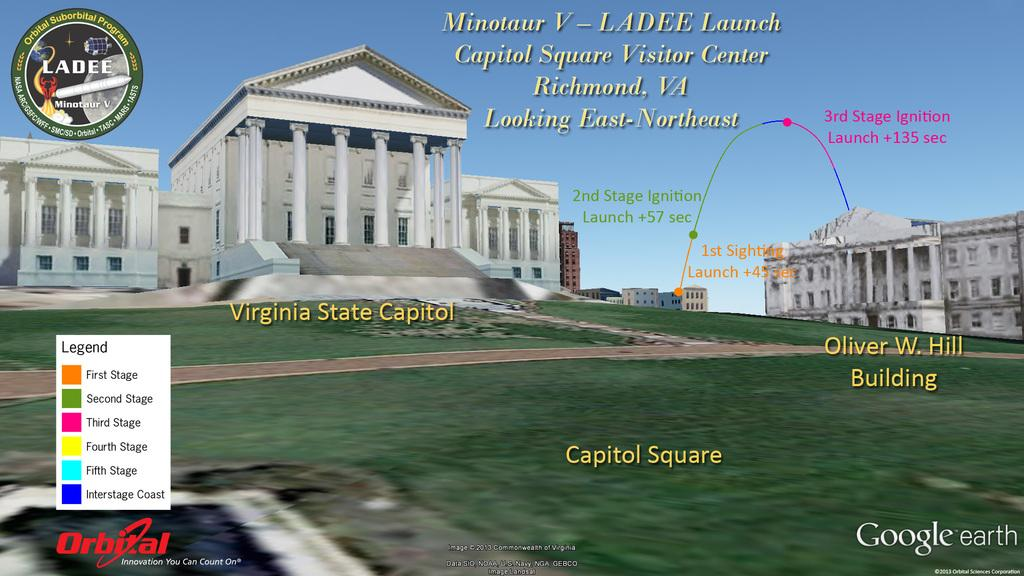What type of surface can be seen in the image? There is ground visible in the image. What structures are present in the image? There are many buildings in the image. What color is the sky in the background of the image? The sky is blue in the background of the image. Is there any text or writing present in the image? Yes, there is text or writing present in the image. How does the beggar interact with the rice in the image? There is no beggar or rice present in the image. 